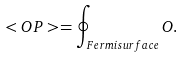Convert formula to latex. <formula><loc_0><loc_0><loc_500><loc_500>< O P > = \oint _ { F e r m i s u r f a c e } O .</formula> 